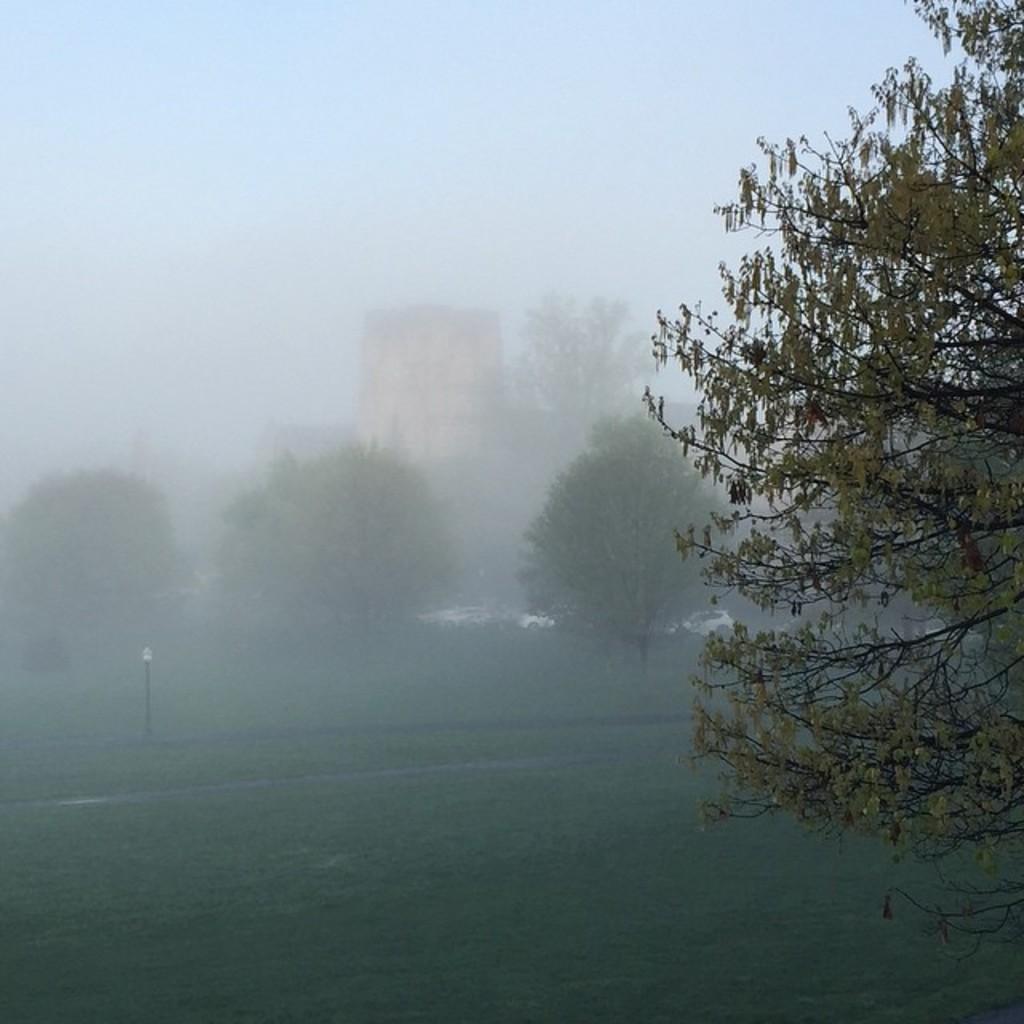In one or two sentences, can you explain what this image depicts? At the bottom of this image, there is grass on the ground. On the right side, there are branches of a tree having leaves. In the background, there are trees, a building, vehicles, smoke and there are clouds in the sky. 